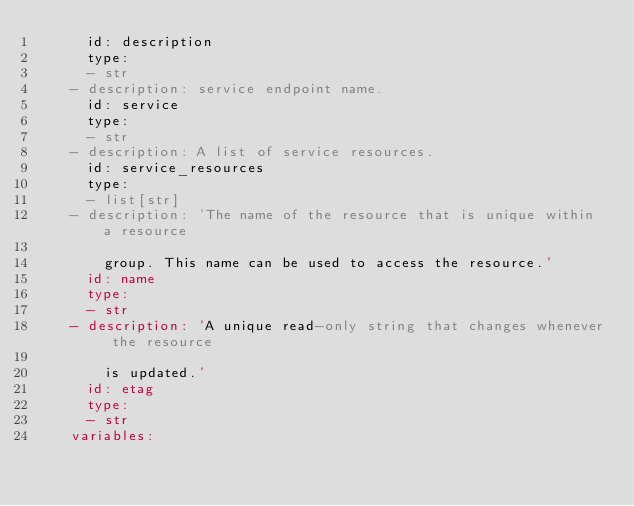<code> <loc_0><loc_0><loc_500><loc_500><_YAML_>      id: description
      type:
      - str
    - description: service endpoint name.
      id: service
      type:
      - str
    - description: A list of service resources.
      id: service_resources
      type:
      - list[str]
    - description: 'The name of the resource that is unique within a resource

        group. This name can be used to access the resource.'
      id: name
      type:
      - str
    - description: 'A unique read-only string that changes whenever the resource

        is updated.'
      id: etag
      type:
      - str
    variables:</code> 